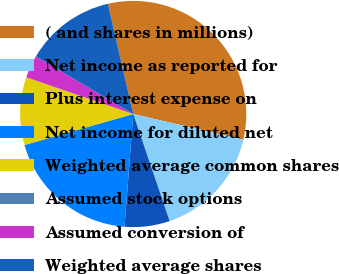<chart> <loc_0><loc_0><loc_500><loc_500><pie_chart><fcel>( and shares in millions)<fcel>Net income as reported for<fcel>Plus interest expense on<fcel>Net income for diluted net<fcel>Weighted average common shares<fcel>Assumed stock options<fcel>Assumed conversion of<fcel>Weighted average shares<nl><fcel>32.25%<fcel>16.13%<fcel>6.45%<fcel>19.35%<fcel>9.68%<fcel>0.01%<fcel>3.23%<fcel>12.9%<nl></chart> 